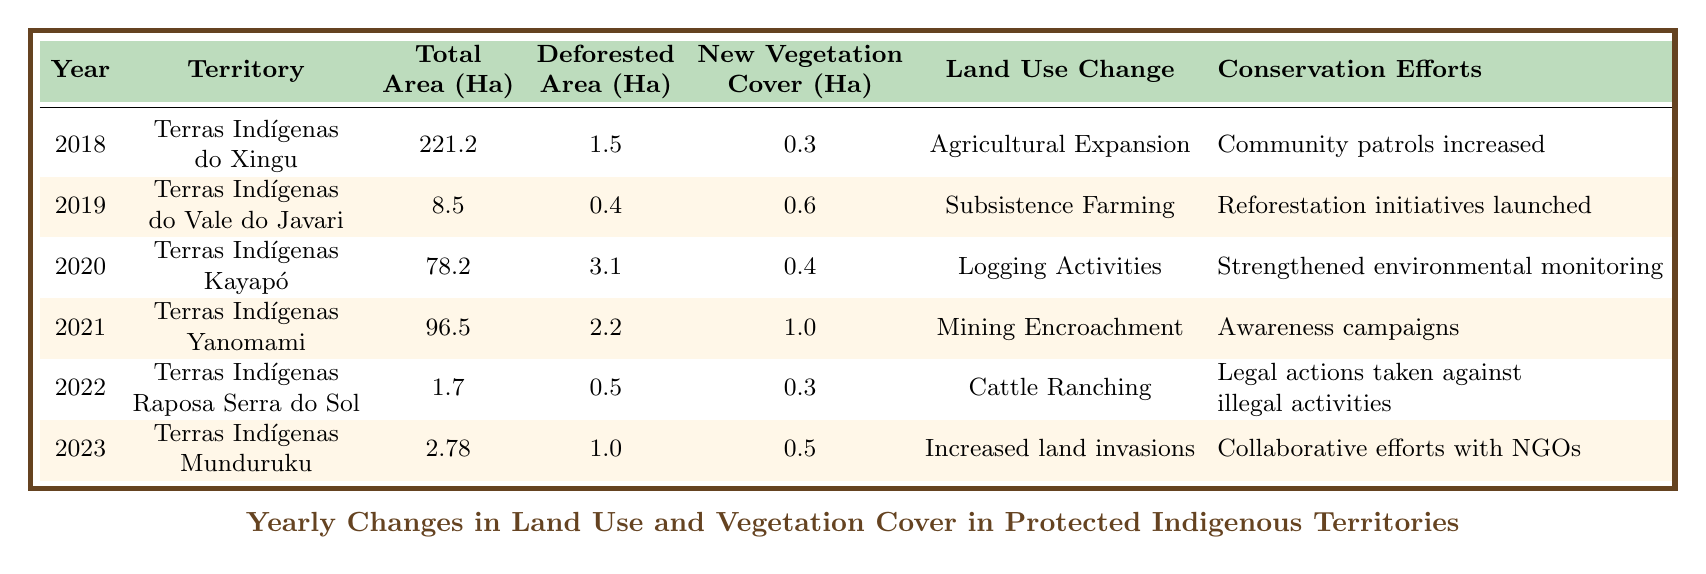What was the total area of Terras Indígenas do Xingu in 2018? The table shows that in 2018, the total area of Terras Indígenas do Xingu is given in the "Total Area (Ha)" column. The value listed is 221.2 hectares.
Answer: 221.2 Which territory experienced logging activities in 2020? According to the table, the "Land Use Change" column indicates that Terras Indígenas Kayapó experienced logging activities in 2020.
Answer: Terras Indígenas Kayapó What is the increase in newly vegetative cover from 2022 to 2023 across the territories? To find the increase, we subtract the "New Vegetation Cover (Ha)" of 2022 (0.3) from that of 2023 (0.5). Thus, the increase is 0.5 - 0.3 = 0.2 hectares.
Answer: 0.2 Did any of the territories have a deforested area greater than 2 hectares? By examining the "Deforested Area (Ha)" column, we see that no territories listed have a deforested area greater than 2 hectares; the highest value is 3.1 for Terras Indígenas Kayapó.
Answer: No What was the total deforested area across all territories from 2018 to 2023? To find the total deforested area, we sum the values in the "Deforested Area (Ha)" column: 1.5 + 0.4 + 3.1 + 2.2 + 0.5 + 1.0 = 8.7 hectares.
Answer: 8.7 Which land use change type was associated with the highest deforested area? By comparing the "Deforested Area (Ha)" column, we find that "Logging Activities" in 2020 has the highest deforested area of 3.1 hectares.
Answer: Logging Activities What were the conservation efforts undertaken in Terras Indígenas do Vale do Javari in 2019? The conservation efforts noted in the table for this territory in 2019 are "Reforestation initiatives launched."
Answer: Reforestation initiatives launched What was the average deforested area for the years provided in the table? To calculate the average, we first sum the deforested areas: (1.5 + 0.4 + 3.1 + 2.2 + 0.5 + 1.0) = 8.7 then divide by the number of years (6). Therefore, 8.7 / 6 = 1.45.
Answer: 1.45 What land use change occurred in the Terras Indígenas Raposa Serra do Sol? According to the table, the land use change in Terras Indígenas Raposa Serra do Sol is "Cattle Ranching."
Answer: Cattle Ranching 